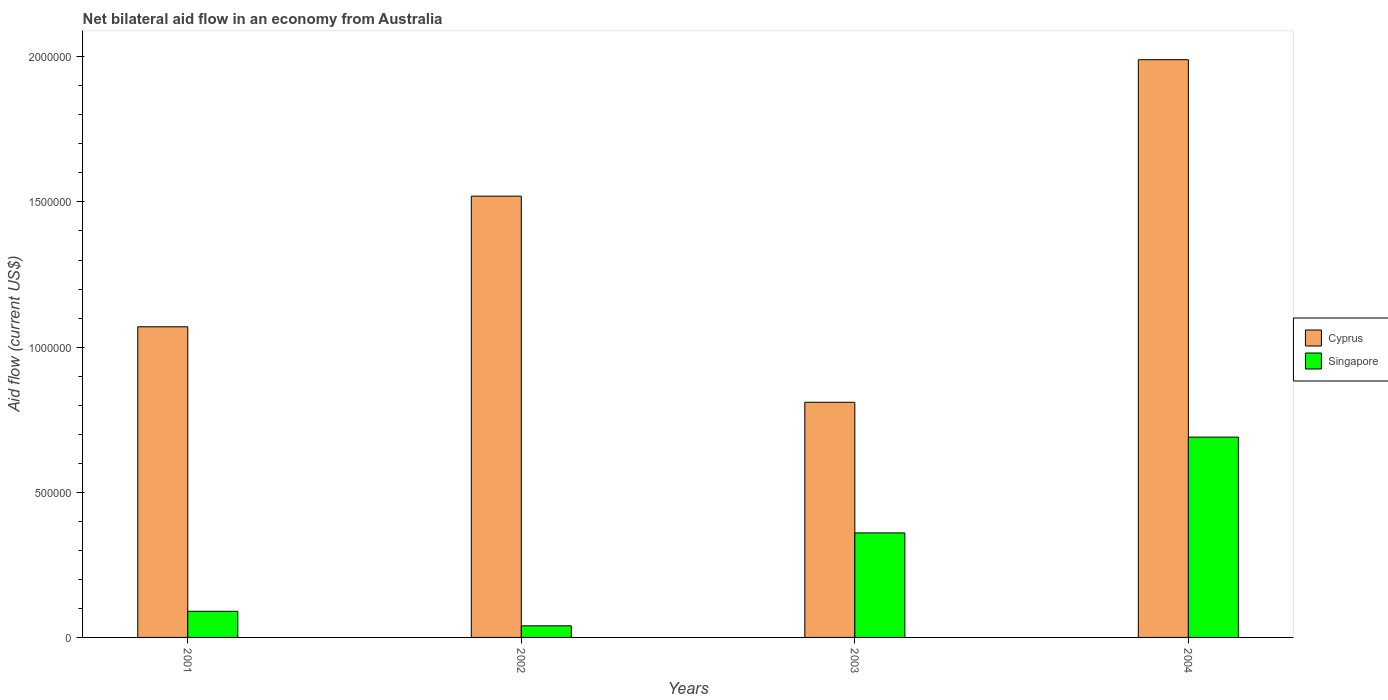How many different coloured bars are there?
Provide a succinct answer. 2. Are the number of bars on each tick of the X-axis equal?
Make the answer very short. Yes. How many bars are there on the 3rd tick from the left?
Your response must be concise. 2. Across all years, what is the maximum net bilateral aid flow in Singapore?
Provide a succinct answer. 6.90e+05. Across all years, what is the minimum net bilateral aid flow in Singapore?
Offer a terse response. 4.00e+04. In which year was the net bilateral aid flow in Singapore minimum?
Your response must be concise. 2002. What is the total net bilateral aid flow in Cyprus in the graph?
Your response must be concise. 5.39e+06. What is the difference between the net bilateral aid flow in Cyprus in 2001 and that in 2002?
Provide a succinct answer. -4.50e+05. What is the difference between the net bilateral aid flow in Singapore in 2003 and the net bilateral aid flow in Cyprus in 2004?
Provide a short and direct response. -1.63e+06. What is the average net bilateral aid flow in Singapore per year?
Your response must be concise. 2.95e+05. In the year 2003, what is the difference between the net bilateral aid flow in Singapore and net bilateral aid flow in Cyprus?
Ensure brevity in your answer.  -4.50e+05. What is the ratio of the net bilateral aid flow in Cyprus in 2002 to that in 2003?
Ensure brevity in your answer.  1.88. Is the net bilateral aid flow in Cyprus in 2003 less than that in 2004?
Ensure brevity in your answer.  Yes. Is the difference between the net bilateral aid flow in Singapore in 2002 and 2004 greater than the difference between the net bilateral aid flow in Cyprus in 2002 and 2004?
Give a very brief answer. No. What is the difference between the highest and the lowest net bilateral aid flow in Cyprus?
Make the answer very short. 1.18e+06. In how many years, is the net bilateral aid flow in Cyprus greater than the average net bilateral aid flow in Cyprus taken over all years?
Your response must be concise. 2. Is the sum of the net bilateral aid flow in Cyprus in 2003 and 2004 greater than the maximum net bilateral aid flow in Singapore across all years?
Your answer should be compact. Yes. What does the 1st bar from the left in 2002 represents?
Offer a very short reply. Cyprus. What does the 2nd bar from the right in 2001 represents?
Offer a very short reply. Cyprus. How many bars are there?
Ensure brevity in your answer.  8. Are all the bars in the graph horizontal?
Keep it short and to the point. No. How many years are there in the graph?
Ensure brevity in your answer.  4. What is the difference between two consecutive major ticks on the Y-axis?
Your answer should be very brief. 5.00e+05. Are the values on the major ticks of Y-axis written in scientific E-notation?
Keep it short and to the point. No. Does the graph contain grids?
Ensure brevity in your answer.  No. How many legend labels are there?
Provide a short and direct response. 2. How are the legend labels stacked?
Your response must be concise. Vertical. What is the title of the graph?
Your answer should be very brief. Net bilateral aid flow in an economy from Australia. What is the label or title of the Y-axis?
Give a very brief answer. Aid flow (current US$). What is the Aid flow (current US$) of Cyprus in 2001?
Offer a terse response. 1.07e+06. What is the Aid flow (current US$) in Cyprus in 2002?
Ensure brevity in your answer.  1.52e+06. What is the Aid flow (current US$) in Singapore in 2002?
Your answer should be very brief. 4.00e+04. What is the Aid flow (current US$) of Cyprus in 2003?
Give a very brief answer. 8.10e+05. What is the Aid flow (current US$) in Cyprus in 2004?
Ensure brevity in your answer.  1.99e+06. What is the Aid flow (current US$) in Singapore in 2004?
Provide a short and direct response. 6.90e+05. Across all years, what is the maximum Aid flow (current US$) of Cyprus?
Offer a terse response. 1.99e+06. Across all years, what is the maximum Aid flow (current US$) in Singapore?
Make the answer very short. 6.90e+05. Across all years, what is the minimum Aid flow (current US$) in Cyprus?
Your answer should be compact. 8.10e+05. Across all years, what is the minimum Aid flow (current US$) in Singapore?
Make the answer very short. 4.00e+04. What is the total Aid flow (current US$) of Cyprus in the graph?
Ensure brevity in your answer.  5.39e+06. What is the total Aid flow (current US$) of Singapore in the graph?
Provide a succinct answer. 1.18e+06. What is the difference between the Aid flow (current US$) in Cyprus in 2001 and that in 2002?
Ensure brevity in your answer.  -4.50e+05. What is the difference between the Aid flow (current US$) of Singapore in 2001 and that in 2003?
Provide a succinct answer. -2.70e+05. What is the difference between the Aid flow (current US$) of Cyprus in 2001 and that in 2004?
Provide a succinct answer. -9.20e+05. What is the difference between the Aid flow (current US$) in Singapore in 2001 and that in 2004?
Ensure brevity in your answer.  -6.00e+05. What is the difference between the Aid flow (current US$) in Cyprus in 2002 and that in 2003?
Ensure brevity in your answer.  7.10e+05. What is the difference between the Aid flow (current US$) in Singapore in 2002 and that in 2003?
Ensure brevity in your answer.  -3.20e+05. What is the difference between the Aid flow (current US$) in Cyprus in 2002 and that in 2004?
Offer a very short reply. -4.70e+05. What is the difference between the Aid flow (current US$) in Singapore in 2002 and that in 2004?
Give a very brief answer. -6.50e+05. What is the difference between the Aid flow (current US$) in Cyprus in 2003 and that in 2004?
Provide a short and direct response. -1.18e+06. What is the difference between the Aid flow (current US$) of Singapore in 2003 and that in 2004?
Keep it short and to the point. -3.30e+05. What is the difference between the Aid flow (current US$) in Cyprus in 2001 and the Aid flow (current US$) in Singapore in 2002?
Give a very brief answer. 1.03e+06. What is the difference between the Aid flow (current US$) in Cyprus in 2001 and the Aid flow (current US$) in Singapore in 2003?
Provide a short and direct response. 7.10e+05. What is the difference between the Aid flow (current US$) of Cyprus in 2001 and the Aid flow (current US$) of Singapore in 2004?
Provide a succinct answer. 3.80e+05. What is the difference between the Aid flow (current US$) of Cyprus in 2002 and the Aid flow (current US$) of Singapore in 2003?
Your answer should be compact. 1.16e+06. What is the difference between the Aid flow (current US$) of Cyprus in 2002 and the Aid flow (current US$) of Singapore in 2004?
Offer a very short reply. 8.30e+05. What is the difference between the Aid flow (current US$) in Cyprus in 2003 and the Aid flow (current US$) in Singapore in 2004?
Your answer should be very brief. 1.20e+05. What is the average Aid flow (current US$) of Cyprus per year?
Ensure brevity in your answer.  1.35e+06. What is the average Aid flow (current US$) of Singapore per year?
Your answer should be compact. 2.95e+05. In the year 2001, what is the difference between the Aid flow (current US$) in Cyprus and Aid flow (current US$) in Singapore?
Provide a short and direct response. 9.80e+05. In the year 2002, what is the difference between the Aid flow (current US$) in Cyprus and Aid flow (current US$) in Singapore?
Provide a succinct answer. 1.48e+06. In the year 2003, what is the difference between the Aid flow (current US$) of Cyprus and Aid flow (current US$) of Singapore?
Provide a short and direct response. 4.50e+05. In the year 2004, what is the difference between the Aid flow (current US$) in Cyprus and Aid flow (current US$) in Singapore?
Provide a short and direct response. 1.30e+06. What is the ratio of the Aid flow (current US$) of Cyprus in 2001 to that in 2002?
Give a very brief answer. 0.7. What is the ratio of the Aid flow (current US$) of Singapore in 2001 to that in 2002?
Your answer should be compact. 2.25. What is the ratio of the Aid flow (current US$) of Cyprus in 2001 to that in 2003?
Your answer should be compact. 1.32. What is the ratio of the Aid flow (current US$) in Cyprus in 2001 to that in 2004?
Ensure brevity in your answer.  0.54. What is the ratio of the Aid flow (current US$) of Singapore in 2001 to that in 2004?
Offer a very short reply. 0.13. What is the ratio of the Aid flow (current US$) of Cyprus in 2002 to that in 2003?
Provide a short and direct response. 1.88. What is the ratio of the Aid flow (current US$) in Cyprus in 2002 to that in 2004?
Ensure brevity in your answer.  0.76. What is the ratio of the Aid flow (current US$) in Singapore in 2002 to that in 2004?
Ensure brevity in your answer.  0.06. What is the ratio of the Aid flow (current US$) in Cyprus in 2003 to that in 2004?
Your answer should be compact. 0.41. What is the ratio of the Aid flow (current US$) in Singapore in 2003 to that in 2004?
Provide a succinct answer. 0.52. What is the difference between the highest and the second highest Aid flow (current US$) in Singapore?
Offer a very short reply. 3.30e+05. What is the difference between the highest and the lowest Aid flow (current US$) of Cyprus?
Keep it short and to the point. 1.18e+06. What is the difference between the highest and the lowest Aid flow (current US$) of Singapore?
Provide a short and direct response. 6.50e+05. 